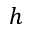<formula> <loc_0><loc_0><loc_500><loc_500>h</formula> 